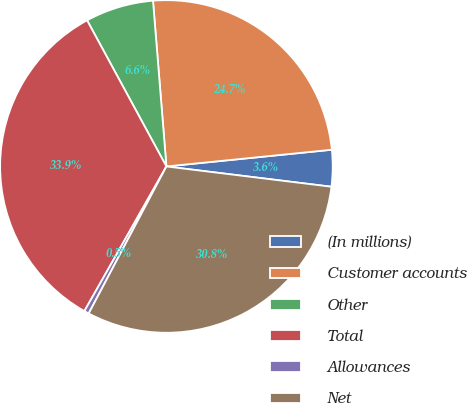<chart> <loc_0><loc_0><loc_500><loc_500><pie_chart><fcel>(In millions)<fcel>Customer accounts<fcel>Other<fcel>Total<fcel>Allowances<fcel>Net<nl><fcel>3.55%<fcel>24.68%<fcel>6.63%<fcel>33.87%<fcel>0.47%<fcel>30.79%<nl></chart> 